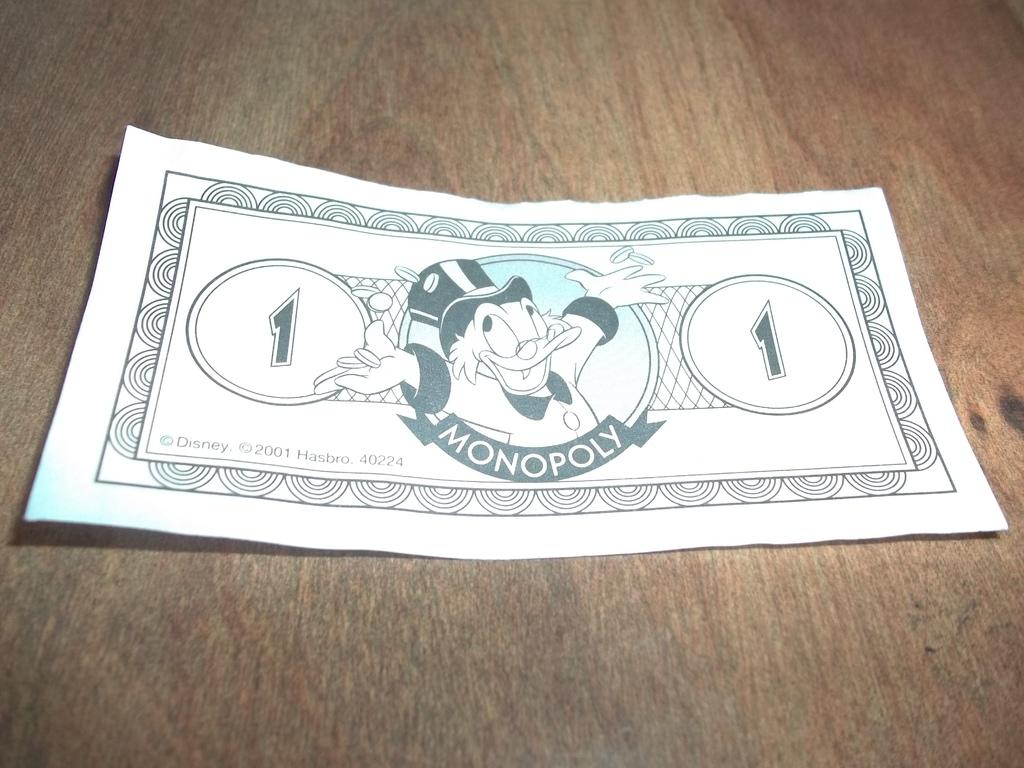What is present on a surface in the image? There is a poster on a wooden surface in the image. What is shown on the poster? The poster depicts a person and has text and numbers on it. How many trees are visible in the image? There are no trees visible in the image; the focus is on the poster on a wooden surface. 